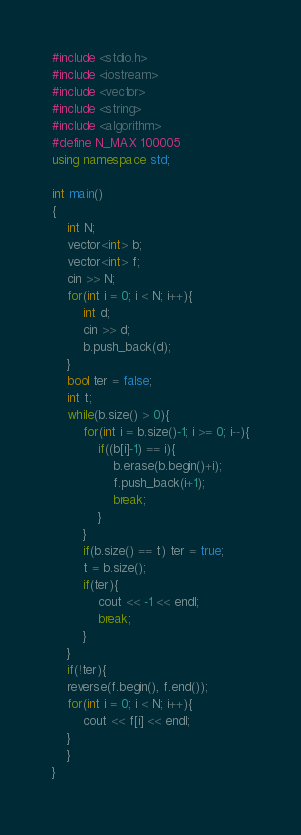<code> <loc_0><loc_0><loc_500><loc_500><_C++_>#include <stdio.h>
#include <iostream>
#include <vector>
#include <string>
#include <algorithm>
#define N_MAX 100005
using namespace std;

int main()
{
	int N;
  	vector<int> b;
  	vector<int> f;
  	cin >> N;
  	for(int i = 0; i < N; i++){
      	int d;
    	cin >> d;
      	b.push_back(d);
    }
  	bool ter = false;
  	int t;
  	while(b.size() > 0){
        for(int i = b.size()-1; i >= 0; i--){
            if((b[i]-1) == i){
                b.erase(b.begin()+i);
                f.push_back(i+1);
                break;
            }
        }
      	if(b.size() == t) ter = true;
      	t = b.size();
      	if(ter){
        	cout << -1 << endl;
          	break;
        }
    }
  	if(!ter){
  	reverse(f.begin(), f.end());
  	for(int i = 0; i < N; i++){
    	cout << f[i] << endl;
    }
    }
}</code> 